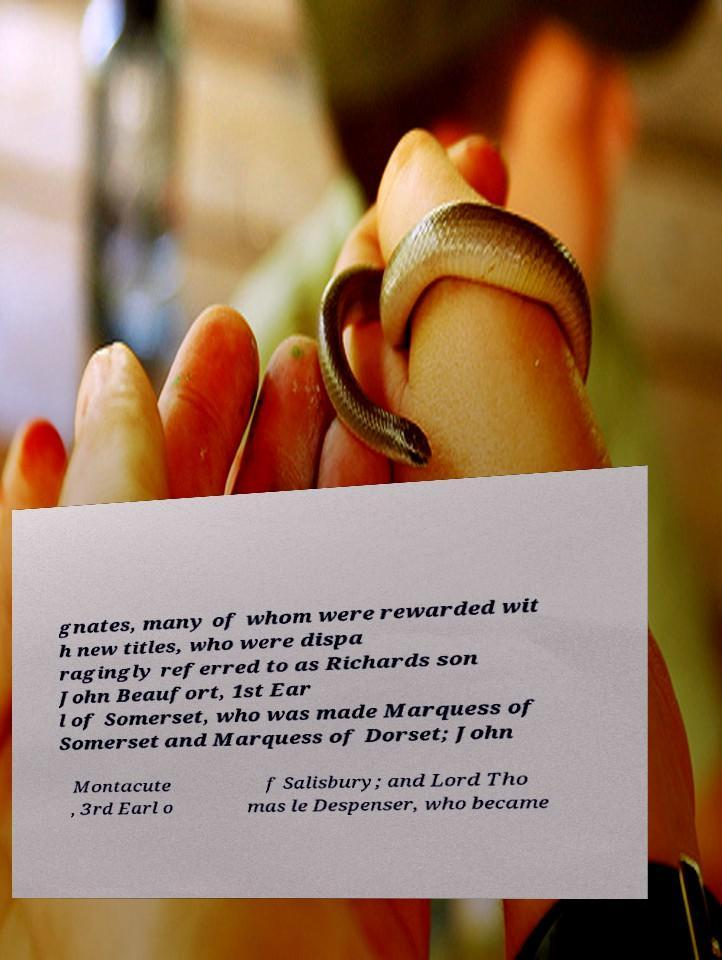For documentation purposes, I need the text within this image transcribed. Could you provide that? gnates, many of whom were rewarded wit h new titles, who were dispa ragingly referred to as Richards son John Beaufort, 1st Ear l of Somerset, who was made Marquess of Somerset and Marquess of Dorset; John Montacute , 3rd Earl o f Salisbury; and Lord Tho mas le Despenser, who became 